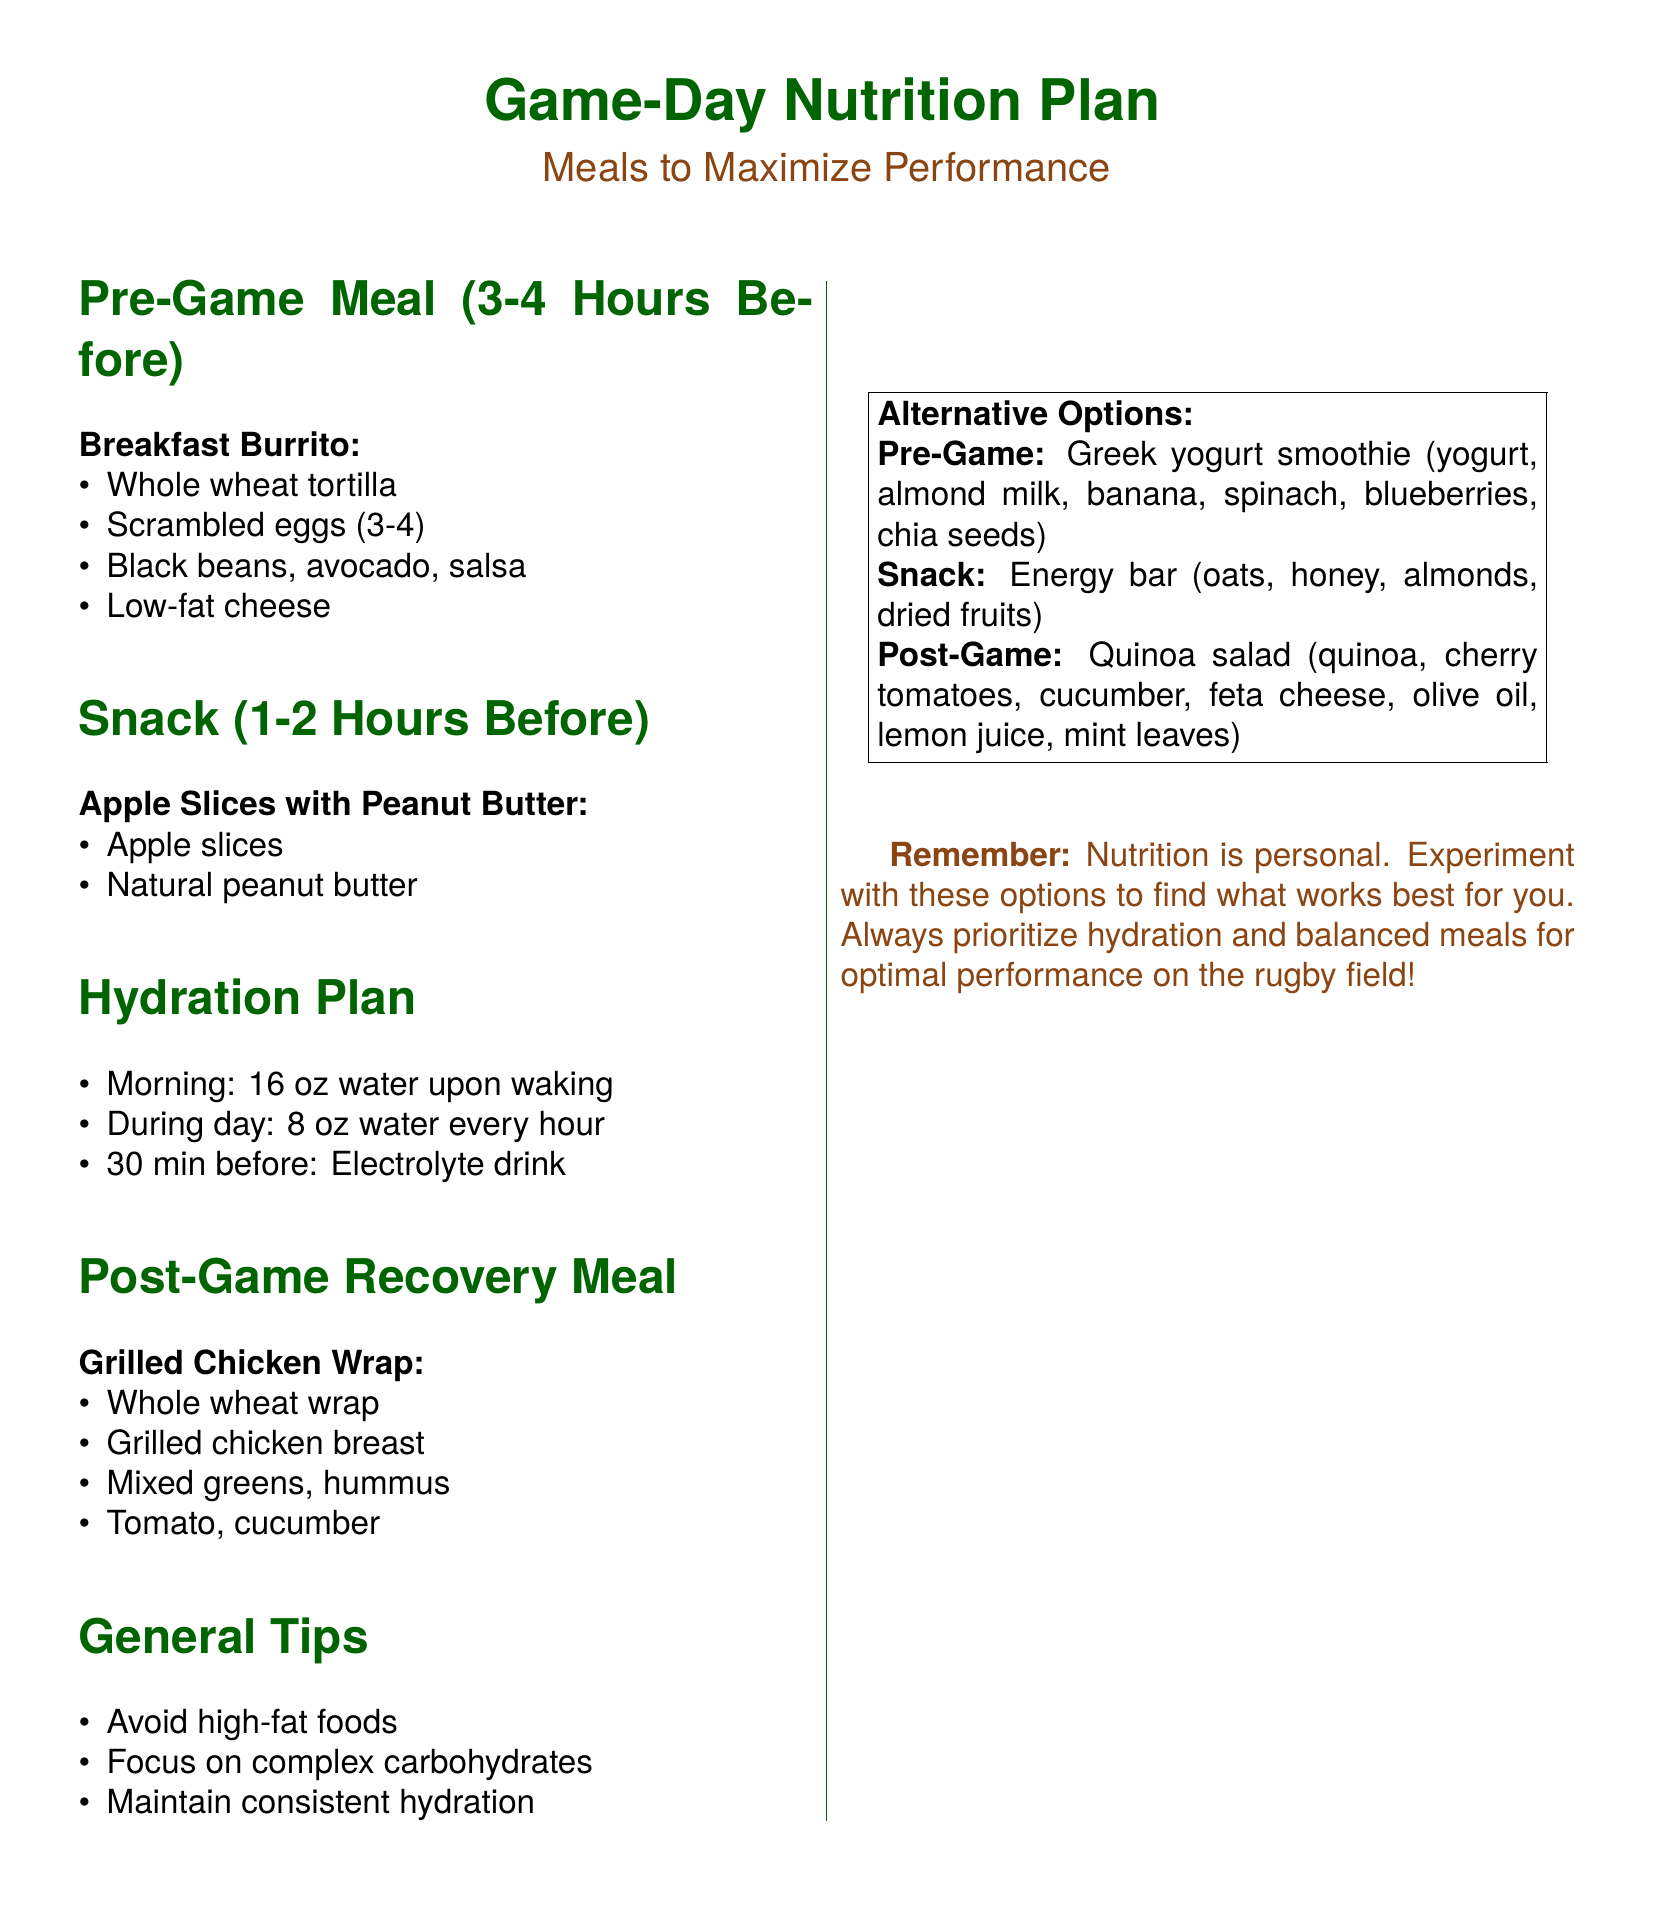what is the pre-game meal? The pre-game meal is a Breakfast Burrito, consisting of a whole wheat tortilla, scrambled eggs, black beans, avocado, salsa, and low-fat cheese.
Answer: Breakfast Burrito how many hours before the game should the pre-game meal be consumed? The pre-game meal should be consumed 3-4 hours before the game.
Answer: 3-4 hours what is the snack option before the game? The snack option before the game is Apple Slices with Peanut Butter.
Answer: Apple Slices with Peanut Butter what is recommended for hydration 30 minutes before the game? It is recommended to have an electrolyte drink 30 minutes before the game.
Answer: Electrolyte drink what type of wrap is suggested for the post-game recovery meal? The suggested wrap for the post-game recovery meal is a whole wheat wrap.
Answer: Whole wheat wrap name one general tip for game-day nutrition. One general tip is to avoid high-fat foods.
Answer: Avoid high-fat foods what is the alternative pre-game option? The alternative pre-game option is a Greek yogurt smoothie.
Answer: Greek yogurt smoothie how often should water be consumed during the day leading up to the game? Water should be consumed 8 oz every hour during the day.
Answer: 8 oz every hour what is the focus of the nutrition plan according to the rugby fan's note? The focus of the nutrition plan is to optimize energy, hydration, and recovery for peak performance.
Answer: Optimize energy, hydration, and recovery 